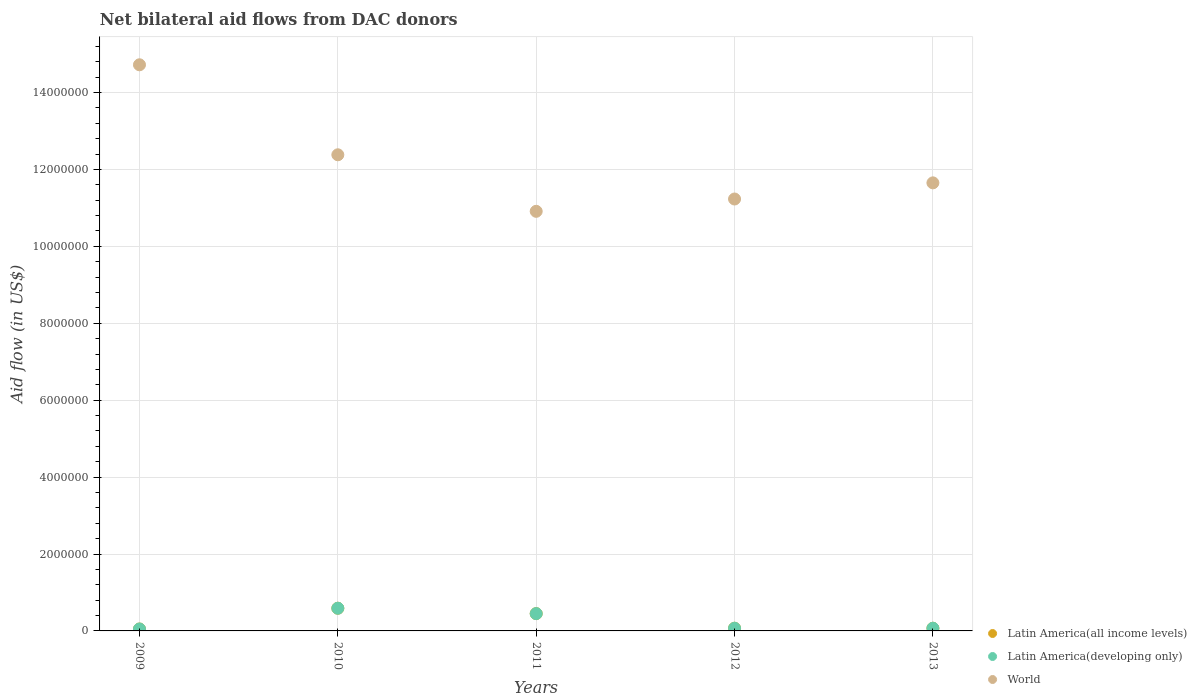How many different coloured dotlines are there?
Your response must be concise. 3. Is the number of dotlines equal to the number of legend labels?
Provide a succinct answer. Yes. What is the net bilateral aid flow in Latin America(all income levels) in 2013?
Ensure brevity in your answer.  7.00e+04. Across all years, what is the maximum net bilateral aid flow in Latin America(developing only)?
Provide a succinct answer. 5.90e+05. Across all years, what is the minimum net bilateral aid flow in Latin America(developing only)?
Your response must be concise. 5.00e+04. What is the total net bilateral aid flow in World in the graph?
Ensure brevity in your answer.  6.09e+07. What is the difference between the net bilateral aid flow in World in 2009 and that in 2010?
Make the answer very short. 2.34e+06. What is the difference between the net bilateral aid flow in World in 2009 and the net bilateral aid flow in Latin America(developing only) in 2010?
Provide a short and direct response. 1.41e+07. What is the average net bilateral aid flow in Latin America(all income levels) per year?
Offer a terse response. 2.46e+05. In the year 2009, what is the difference between the net bilateral aid flow in World and net bilateral aid flow in Latin America(all income levels)?
Provide a short and direct response. 1.47e+07. In how many years, is the net bilateral aid flow in Latin America(developing only) greater than 3200000 US$?
Keep it short and to the point. 0. What is the difference between the highest and the lowest net bilateral aid flow in World?
Your answer should be compact. 3.81e+06. Is the sum of the net bilateral aid flow in World in 2010 and 2011 greater than the maximum net bilateral aid flow in Latin America(developing only) across all years?
Give a very brief answer. Yes. Is it the case that in every year, the sum of the net bilateral aid flow in World and net bilateral aid flow in Latin America(developing only)  is greater than the net bilateral aid flow in Latin America(all income levels)?
Ensure brevity in your answer.  Yes. Does the net bilateral aid flow in World monotonically increase over the years?
Provide a succinct answer. No. Is the net bilateral aid flow in World strictly less than the net bilateral aid flow in Latin America(all income levels) over the years?
Your answer should be very brief. No. How many dotlines are there?
Your answer should be very brief. 3. Are the values on the major ticks of Y-axis written in scientific E-notation?
Offer a terse response. No. Does the graph contain any zero values?
Ensure brevity in your answer.  No. Does the graph contain grids?
Give a very brief answer. Yes. Where does the legend appear in the graph?
Your answer should be compact. Bottom right. How are the legend labels stacked?
Your answer should be compact. Vertical. What is the title of the graph?
Offer a terse response. Net bilateral aid flows from DAC donors. What is the label or title of the Y-axis?
Ensure brevity in your answer.  Aid flow (in US$). What is the Aid flow (in US$) in Latin America(all income levels) in 2009?
Provide a succinct answer. 5.00e+04. What is the Aid flow (in US$) of World in 2009?
Your answer should be compact. 1.47e+07. What is the Aid flow (in US$) in Latin America(all income levels) in 2010?
Offer a terse response. 5.90e+05. What is the Aid flow (in US$) of Latin America(developing only) in 2010?
Provide a short and direct response. 5.90e+05. What is the Aid flow (in US$) in World in 2010?
Your response must be concise. 1.24e+07. What is the Aid flow (in US$) in Latin America(developing only) in 2011?
Keep it short and to the point. 4.50e+05. What is the Aid flow (in US$) in World in 2011?
Keep it short and to the point. 1.09e+07. What is the Aid flow (in US$) of World in 2012?
Keep it short and to the point. 1.12e+07. What is the Aid flow (in US$) in Latin America(developing only) in 2013?
Your answer should be compact. 7.00e+04. What is the Aid flow (in US$) in World in 2013?
Your answer should be very brief. 1.16e+07. Across all years, what is the maximum Aid flow (in US$) in Latin America(all income levels)?
Ensure brevity in your answer.  5.90e+05. Across all years, what is the maximum Aid flow (in US$) of Latin America(developing only)?
Ensure brevity in your answer.  5.90e+05. Across all years, what is the maximum Aid flow (in US$) of World?
Keep it short and to the point. 1.47e+07. Across all years, what is the minimum Aid flow (in US$) of Latin America(all income levels)?
Offer a very short reply. 5.00e+04. Across all years, what is the minimum Aid flow (in US$) in World?
Ensure brevity in your answer.  1.09e+07. What is the total Aid flow (in US$) in Latin America(all income levels) in the graph?
Ensure brevity in your answer.  1.23e+06. What is the total Aid flow (in US$) in Latin America(developing only) in the graph?
Your response must be concise. 1.23e+06. What is the total Aid flow (in US$) in World in the graph?
Offer a terse response. 6.09e+07. What is the difference between the Aid flow (in US$) in Latin America(all income levels) in 2009 and that in 2010?
Offer a very short reply. -5.40e+05. What is the difference between the Aid flow (in US$) of Latin America(developing only) in 2009 and that in 2010?
Offer a very short reply. -5.40e+05. What is the difference between the Aid flow (in US$) of World in 2009 and that in 2010?
Your answer should be compact. 2.34e+06. What is the difference between the Aid flow (in US$) of Latin America(all income levels) in 2009 and that in 2011?
Your answer should be very brief. -4.00e+05. What is the difference between the Aid flow (in US$) of Latin America(developing only) in 2009 and that in 2011?
Your response must be concise. -4.00e+05. What is the difference between the Aid flow (in US$) in World in 2009 and that in 2011?
Your response must be concise. 3.81e+06. What is the difference between the Aid flow (in US$) in World in 2009 and that in 2012?
Your answer should be compact. 3.49e+06. What is the difference between the Aid flow (in US$) of Latin America(all income levels) in 2009 and that in 2013?
Keep it short and to the point. -2.00e+04. What is the difference between the Aid flow (in US$) of Latin America(developing only) in 2009 and that in 2013?
Give a very brief answer. -2.00e+04. What is the difference between the Aid flow (in US$) in World in 2009 and that in 2013?
Give a very brief answer. 3.07e+06. What is the difference between the Aid flow (in US$) of Latin America(all income levels) in 2010 and that in 2011?
Your answer should be compact. 1.40e+05. What is the difference between the Aid flow (in US$) of World in 2010 and that in 2011?
Offer a very short reply. 1.47e+06. What is the difference between the Aid flow (in US$) of Latin America(all income levels) in 2010 and that in 2012?
Your response must be concise. 5.20e+05. What is the difference between the Aid flow (in US$) in Latin America(developing only) in 2010 and that in 2012?
Provide a short and direct response. 5.20e+05. What is the difference between the Aid flow (in US$) of World in 2010 and that in 2012?
Ensure brevity in your answer.  1.15e+06. What is the difference between the Aid flow (in US$) of Latin America(all income levels) in 2010 and that in 2013?
Keep it short and to the point. 5.20e+05. What is the difference between the Aid flow (in US$) in Latin America(developing only) in 2010 and that in 2013?
Provide a succinct answer. 5.20e+05. What is the difference between the Aid flow (in US$) in World in 2010 and that in 2013?
Provide a short and direct response. 7.30e+05. What is the difference between the Aid flow (in US$) in Latin America(all income levels) in 2011 and that in 2012?
Make the answer very short. 3.80e+05. What is the difference between the Aid flow (in US$) of Latin America(developing only) in 2011 and that in 2012?
Ensure brevity in your answer.  3.80e+05. What is the difference between the Aid flow (in US$) in World in 2011 and that in 2012?
Offer a very short reply. -3.20e+05. What is the difference between the Aid flow (in US$) in Latin America(all income levels) in 2011 and that in 2013?
Keep it short and to the point. 3.80e+05. What is the difference between the Aid flow (in US$) in World in 2011 and that in 2013?
Offer a very short reply. -7.40e+05. What is the difference between the Aid flow (in US$) of Latin America(all income levels) in 2012 and that in 2013?
Your answer should be very brief. 0. What is the difference between the Aid flow (in US$) in Latin America(developing only) in 2012 and that in 2013?
Keep it short and to the point. 0. What is the difference between the Aid flow (in US$) of World in 2012 and that in 2013?
Your answer should be compact. -4.20e+05. What is the difference between the Aid flow (in US$) in Latin America(all income levels) in 2009 and the Aid flow (in US$) in Latin America(developing only) in 2010?
Provide a succinct answer. -5.40e+05. What is the difference between the Aid flow (in US$) in Latin America(all income levels) in 2009 and the Aid flow (in US$) in World in 2010?
Give a very brief answer. -1.23e+07. What is the difference between the Aid flow (in US$) in Latin America(developing only) in 2009 and the Aid flow (in US$) in World in 2010?
Your answer should be compact. -1.23e+07. What is the difference between the Aid flow (in US$) in Latin America(all income levels) in 2009 and the Aid flow (in US$) in Latin America(developing only) in 2011?
Your answer should be compact. -4.00e+05. What is the difference between the Aid flow (in US$) of Latin America(all income levels) in 2009 and the Aid flow (in US$) of World in 2011?
Ensure brevity in your answer.  -1.09e+07. What is the difference between the Aid flow (in US$) of Latin America(developing only) in 2009 and the Aid flow (in US$) of World in 2011?
Offer a terse response. -1.09e+07. What is the difference between the Aid flow (in US$) of Latin America(all income levels) in 2009 and the Aid flow (in US$) of Latin America(developing only) in 2012?
Give a very brief answer. -2.00e+04. What is the difference between the Aid flow (in US$) in Latin America(all income levels) in 2009 and the Aid flow (in US$) in World in 2012?
Offer a very short reply. -1.12e+07. What is the difference between the Aid flow (in US$) in Latin America(developing only) in 2009 and the Aid flow (in US$) in World in 2012?
Give a very brief answer. -1.12e+07. What is the difference between the Aid flow (in US$) of Latin America(all income levels) in 2009 and the Aid flow (in US$) of Latin America(developing only) in 2013?
Provide a short and direct response. -2.00e+04. What is the difference between the Aid flow (in US$) in Latin America(all income levels) in 2009 and the Aid flow (in US$) in World in 2013?
Keep it short and to the point. -1.16e+07. What is the difference between the Aid flow (in US$) of Latin America(developing only) in 2009 and the Aid flow (in US$) of World in 2013?
Give a very brief answer. -1.16e+07. What is the difference between the Aid flow (in US$) in Latin America(all income levels) in 2010 and the Aid flow (in US$) in World in 2011?
Offer a very short reply. -1.03e+07. What is the difference between the Aid flow (in US$) of Latin America(developing only) in 2010 and the Aid flow (in US$) of World in 2011?
Keep it short and to the point. -1.03e+07. What is the difference between the Aid flow (in US$) of Latin America(all income levels) in 2010 and the Aid flow (in US$) of Latin America(developing only) in 2012?
Provide a succinct answer. 5.20e+05. What is the difference between the Aid flow (in US$) in Latin America(all income levels) in 2010 and the Aid flow (in US$) in World in 2012?
Offer a terse response. -1.06e+07. What is the difference between the Aid flow (in US$) of Latin America(developing only) in 2010 and the Aid flow (in US$) of World in 2012?
Give a very brief answer. -1.06e+07. What is the difference between the Aid flow (in US$) in Latin America(all income levels) in 2010 and the Aid flow (in US$) in Latin America(developing only) in 2013?
Provide a short and direct response. 5.20e+05. What is the difference between the Aid flow (in US$) of Latin America(all income levels) in 2010 and the Aid flow (in US$) of World in 2013?
Give a very brief answer. -1.11e+07. What is the difference between the Aid flow (in US$) in Latin America(developing only) in 2010 and the Aid flow (in US$) in World in 2013?
Provide a succinct answer. -1.11e+07. What is the difference between the Aid flow (in US$) of Latin America(all income levels) in 2011 and the Aid flow (in US$) of World in 2012?
Offer a terse response. -1.08e+07. What is the difference between the Aid flow (in US$) in Latin America(developing only) in 2011 and the Aid flow (in US$) in World in 2012?
Keep it short and to the point. -1.08e+07. What is the difference between the Aid flow (in US$) of Latin America(all income levels) in 2011 and the Aid flow (in US$) of World in 2013?
Your response must be concise. -1.12e+07. What is the difference between the Aid flow (in US$) in Latin America(developing only) in 2011 and the Aid flow (in US$) in World in 2013?
Provide a short and direct response. -1.12e+07. What is the difference between the Aid flow (in US$) in Latin America(all income levels) in 2012 and the Aid flow (in US$) in Latin America(developing only) in 2013?
Your answer should be compact. 0. What is the difference between the Aid flow (in US$) of Latin America(all income levels) in 2012 and the Aid flow (in US$) of World in 2013?
Give a very brief answer. -1.16e+07. What is the difference between the Aid flow (in US$) in Latin America(developing only) in 2012 and the Aid flow (in US$) in World in 2013?
Ensure brevity in your answer.  -1.16e+07. What is the average Aid flow (in US$) in Latin America(all income levels) per year?
Offer a terse response. 2.46e+05. What is the average Aid flow (in US$) in Latin America(developing only) per year?
Keep it short and to the point. 2.46e+05. What is the average Aid flow (in US$) of World per year?
Give a very brief answer. 1.22e+07. In the year 2009, what is the difference between the Aid flow (in US$) in Latin America(all income levels) and Aid flow (in US$) in World?
Your answer should be compact. -1.47e+07. In the year 2009, what is the difference between the Aid flow (in US$) in Latin America(developing only) and Aid flow (in US$) in World?
Provide a succinct answer. -1.47e+07. In the year 2010, what is the difference between the Aid flow (in US$) in Latin America(all income levels) and Aid flow (in US$) in World?
Your response must be concise. -1.18e+07. In the year 2010, what is the difference between the Aid flow (in US$) in Latin America(developing only) and Aid flow (in US$) in World?
Your answer should be very brief. -1.18e+07. In the year 2011, what is the difference between the Aid flow (in US$) in Latin America(all income levels) and Aid flow (in US$) in World?
Your answer should be compact. -1.05e+07. In the year 2011, what is the difference between the Aid flow (in US$) of Latin America(developing only) and Aid flow (in US$) of World?
Your answer should be compact. -1.05e+07. In the year 2012, what is the difference between the Aid flow (in US$) in Latin America(all income levels) and Aid flow (in US$) in Latin America(developing only)?
Provide a short and direct response. 0. In the year 2012, what is the difference between the Aid flow (in US$) in Latin America(all income levels) and Aid flow (in US$) in World?
Your answer should be compact. -1.12e+07. In the year 2012, what is the difference between the Aid flow (in US$) in Latin America(developing only) and Aid flow (in US$) in World?
Your answer should be very brief. -1.12e+07. In the year 2013, what is the difference between the Aid flow (in US$) in Latin America(all income levels) and Aid flow (in US$) in Latin America(developing only)?
Ensure brevity in your answer.  0. In the year 2013, what is the difference between the Aid flow (in US$) in Latin America(all income levels) and Aid flow (in US$) in World?
Make the answer very short. -1.16e+07. In the year 2013, what is the difference between the Aid flow (in US$) of Latin America(developing only) and Aid flow (in US$) of World?
Ensure brevity in your answer.  -1.16e+07. What is the ratio of the Aid flow (in US$) in Latin America(all income levels) in 2009 to that in 2010?
Your answer should be compact. 0.08. What is the ratio of the Aid flow (in US$) in Latin America(developing only) in 2009 to that in 2010?
Keep it short and to the point. 0.08. What is the ratio of the Aid flow (in US$) in World in 2009 to that in 2010?
Provide a short and direct response. 1.19. What is the ratio of the Aid flow (in US$) of Latin America(all income levels) in 2009 to that in 2011?
Your answer should be compact. 0.11. What is the ratio of the Aid flow (in US$) in World in 2009 to that in 2011?
Provide a succinct answer. 1.35. What is the ratio of the Aid flow (in US$) of World in 2009 to that in 2012?
Your answer should be very brief. 1.31. What is the ratio of the Aid flow (in US$) in World in 2009 to that in 2013?
Ensure brevity in your answer.  1.26. What is the ratio of the Aid flow (in US$) of Latin America(all income levels) in 2010 to that in 2011?
Provide a short and direct response. 1.31. What is the ratio of the Aid flow (in US$) of Latin America(developing only) in 2010 to that in 2011?
Give a very brief answer. 1.31. What is the ratio of the Aid flow (in US$) of World in 2010 to that in 2011?
Your response must be concise. 1.13. What is the ratio of the Aid flow (in US$) of Latin America(all income levels) in 2010 to that in 2012?
Keep it short and to the point. 8.43. What is the ratio of the Aid flow (in US$) of Latin America(developing only) in 2010 to that in 2012?
Offer a terse response. 8.43. What is the ratio of the Aid flow (in US$) of World in 2010 to that in 2012?
Offer a very short reply. 1.1. What is the ratio of the Aid flow (in US$) in Latin America(all income levels) in 2010 to that in 2013?
Your answer should be very brief. 8.43. What is the ratio of the Aid flow (in US$) of Latin America(developing only) in 2010 to that in 2013?
Make the answer very short. 8.43. What is the ratio of the Aid flow (in US$) in World in 2010 to that in 2013?
Your answer should be compact. 1.06. What is the ratio of the Aid flow (in US$) of Latin America(all income levels) in 2011 to that in 2012?
Offer a terse response. 6.43. What is the ratio of the Aid flow (in US$) of Latin America(developing only) in 2011 to that in 2012?
Provide a succinct answer. 6.43. What is the ratio of the Aid flow (in US$) in World in 2011 to that in 2012?
Give a very brief answer. 0.97. What is the ratio of the Aid flow (in US$) in Latin America(all income levels) in 2011 to that in 2013?
Make the answer very short. 6.43. What is the ratio of the Aid flow (in US$) in Latin America(developing only) in 2011 to that in 2013?
Provide a short and direct response. 6.43. What is the ratio of the Aid flow (in US$) in World in 2011 to that in 2013?
Provide a short and direct response. 0.94. What is the ratio of the Aid flow (in US$) of Latin America(all income levels) in 2012 to that in 2013?
Offer a very short reply. 1. What is the ratio of the Aid flow (in US$) of World in 2012 to that in 2013?
Ensure brevity in your answer.  0.96. What is the difference between the highest and the second highest Aid flow (in US$) in Latin America(all income levels)?
Make the answer very short. 1.40e+05. What is the difference between the highest and the second highest Aid flow (in US$) in World?
Ensure brevity in your answer.  2.34e+06. What is the difference between the highest and the lowest Aid flow (in US$) in Latin America(all income levels)?
Your answer should be compact. 5.40e+05. What is the difference between the highest and the lowest Aid flow (in US$) in Latin America(developing only)?
Make the answer very short. 5.40e+05. What is the difference between the highest and the lowest Aid flow (in US$) in World?
Provide a succinct answer. 3.81e+06. 